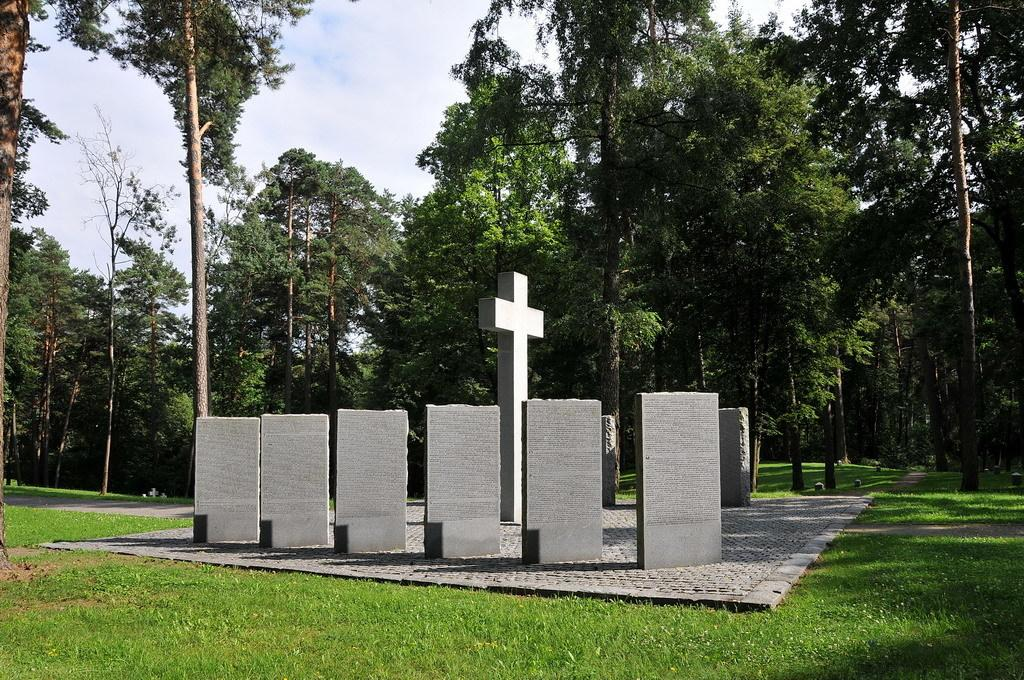What type of natural elements can be seen in the image? There are stones, grass, trees, and the sky visible in the image. What religious symbol is present in the image? There is a holy cross symbol in the image. What type of ground surface is visible in the image? There is grass on the ground in the image. What type of vase is placed on the tree in the image? There is no vase present in the image, and no vase is placed on the tree. How many birds can be seen flying in the sky in the image? There are no birds visible in the image; only the sky is visible at the top. 